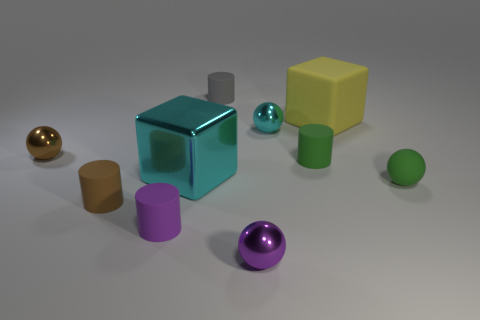There is a big block in front of the large rubber cube; does it have the same color as the tiny ball that is behind the brown metal object?
Offer a very short reply. Yes. There is a rubber thing that is both in front of the gray object and behind the cyan sphere; what color is it?
Make the answer very short. Yellow. What number of other things are the same shape as the small cyan thing?
Provide a succinct answer. 3. The rubber sphere that is the same size as the brown matte cylinder is what color?
Your response must be concise. Green. The cylinder right of the cyan ball is what color?
Provide a short and direct response. Green. There is a small sphere that is in front of the small brown matte object; are there any tiny gray objects to the left of it?
Make the answer very short. Yes. Is the shape of the brown rubber object the same as the tiny metallic thing that is left of the cyan cube?
Give a very brief answer. No. There is a cylinder that is both on the right side of the purple matte object and left of the small purple metallic object; how big is it?
Offer a very short reply. Small. Is there a big cyan cube that has the same material as the cyan sphere?
Offer a very short reply. Yes. The cylinder that is the same color as the matte sphere is what size?
Keep it short and to the point. Small. 